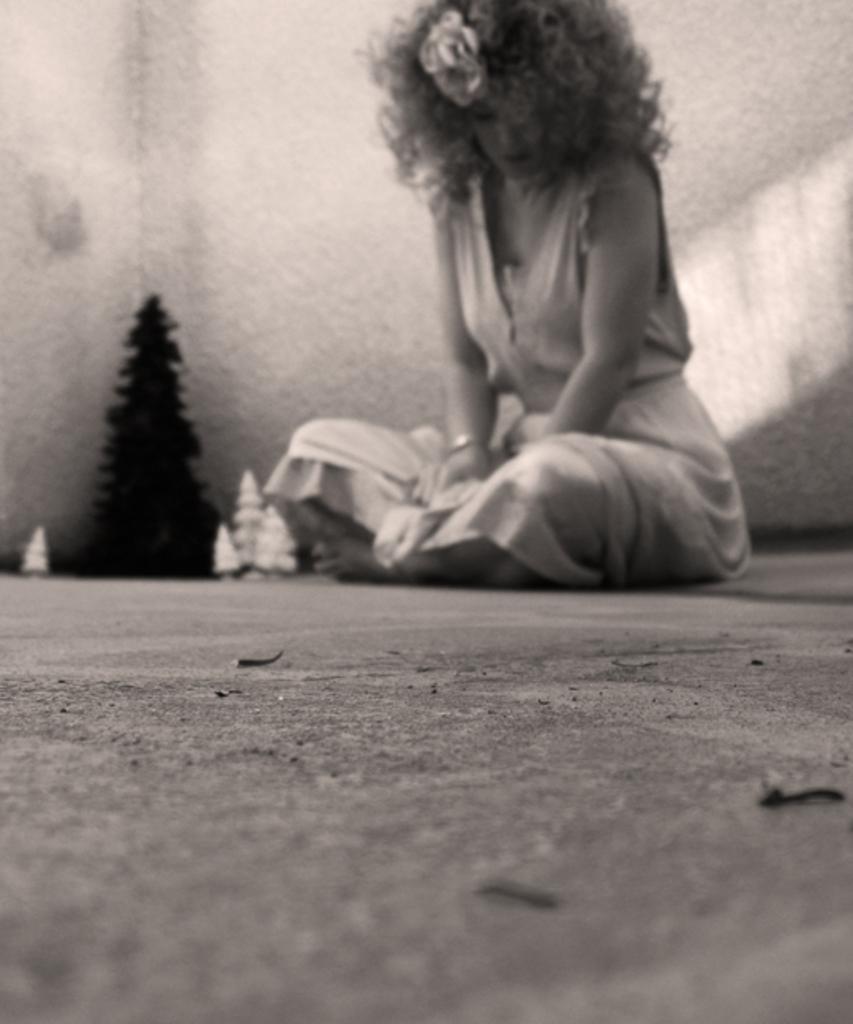Describe this image in one or two sentences. In this picture we can see a woman sitting on the floor. There is a Christmas tree and few white objects on the floor. A wall is visible in the background. 